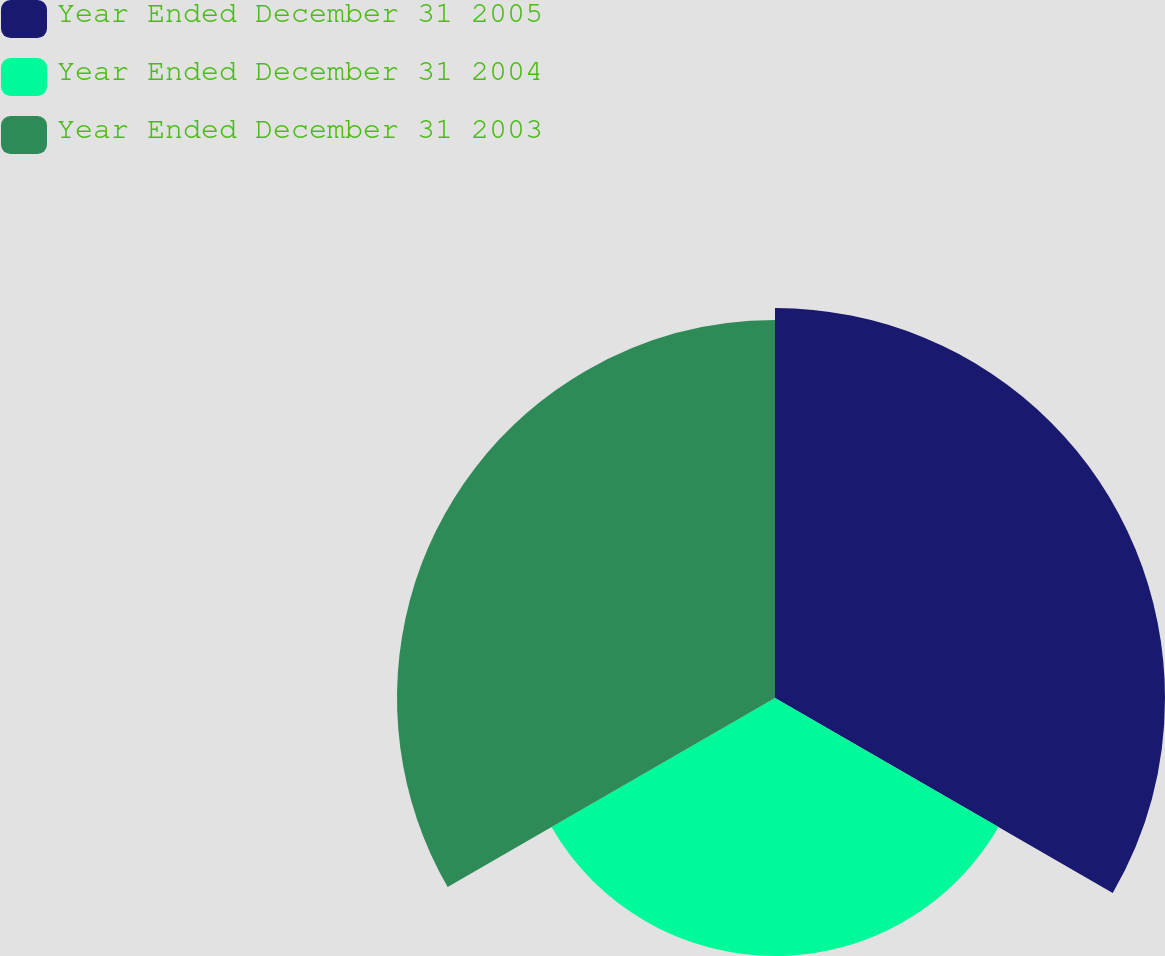<chart> <loc_0><loc_0><loc_500><loc_500><pie_chart><fcel>Year Ended December 31 2005<fcel>Year Ended December 31 2004<fcel>Year Ended December 31 2003<nl><fcel>38.01%<fcel>25.15%<fcel>36.84%<nl></chart> 